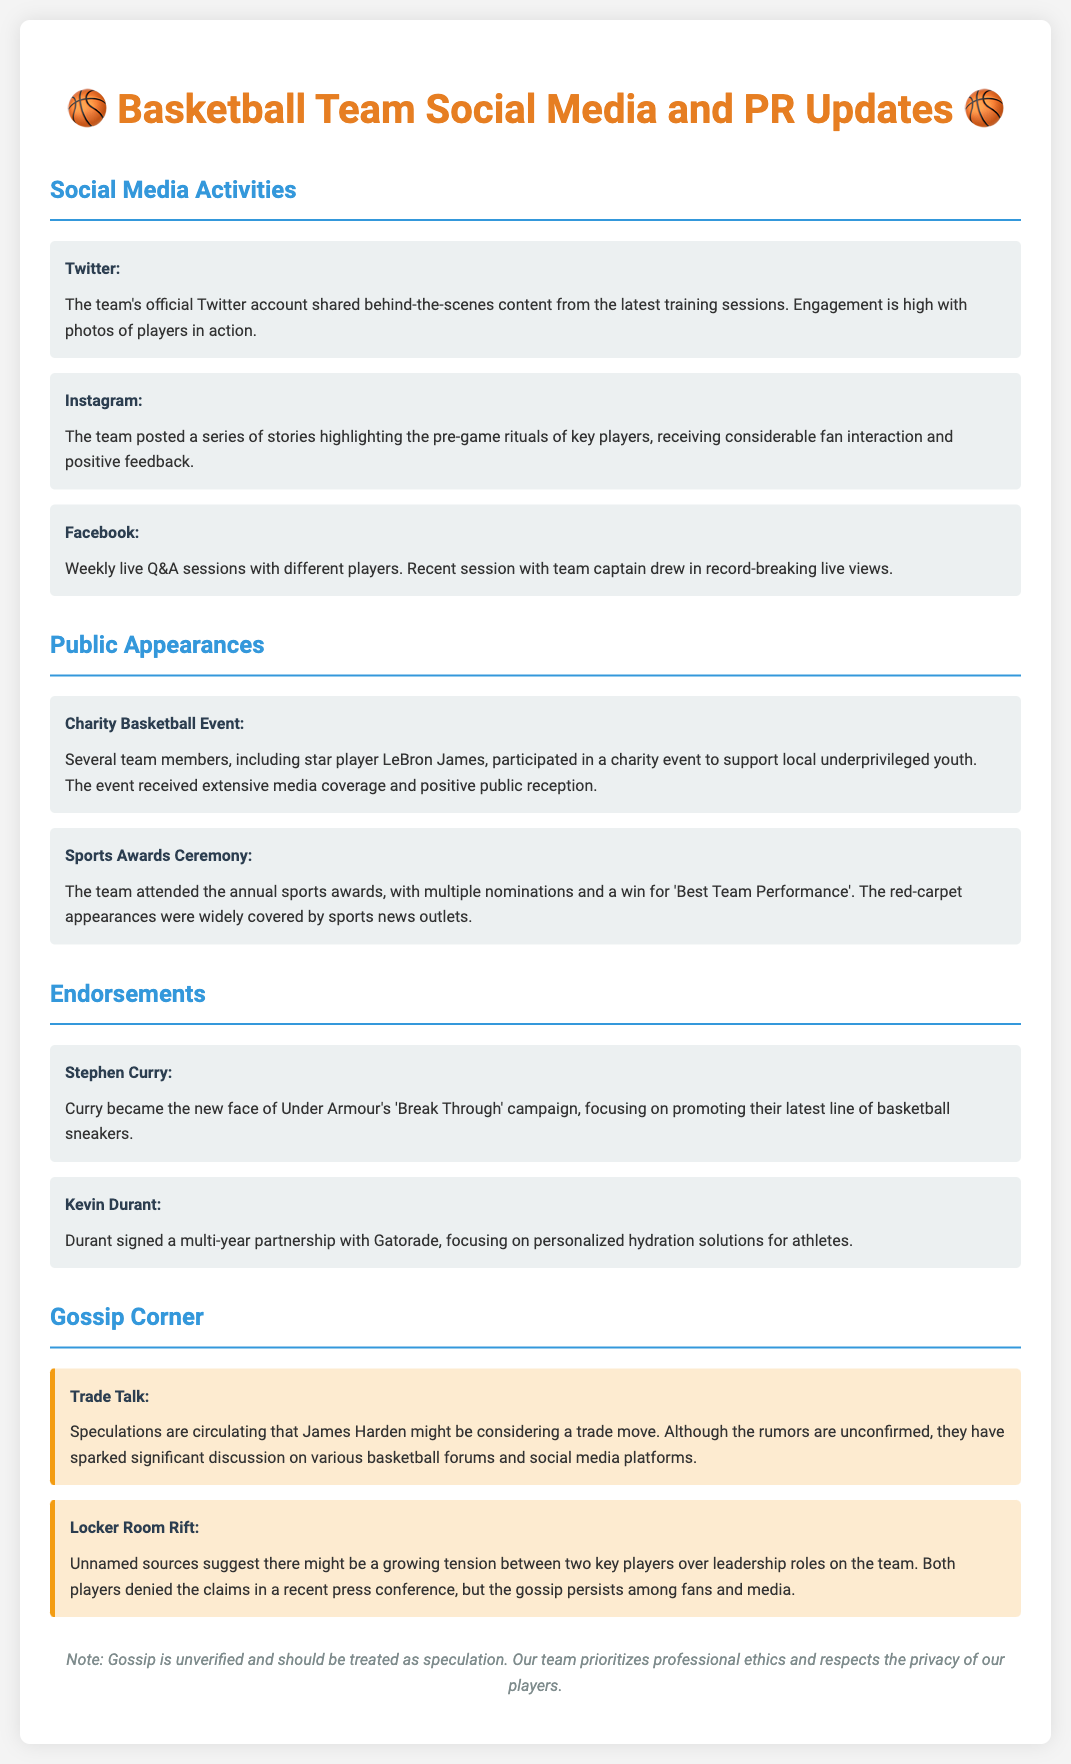What social media platform showcased behind-the-scenes training content? The platform mentioned in the document for showcasing behind-the-scenes training content is Twitter.
Answer: Twitter Which player is the face of Under Armour's 'Break Through' campaign? The document states that Stephen Curry became the new face of Under Armour's 'Break Through' campaign.
Answer: Stephen Curry What event did LeBron James participate in for charity? The document describes a charity basketball event that LeBron James participated in to support local underprivileged youth.
Answer: Charity Basketball Event How many players attended the annual sports awards? The document does not specify an exact number of players but indicates that several team members attended the sports awards.
Answer: Several What is the rumor circulating about James Harden? The document mentions speculations that James Harden might be considering a trade move.
Answer: Trade move Which player signed a partnership with Gatorade? The document specifies that Kevin Durant signed a multi-year partnership with Gatorade.
Answer: Kevin Durant What kind of feedback did the Instagram pre-game ritual stories receive? The document states that the Instagram stories received considerable fan interaction and positive feedback.
Answer: Positive feedback What were two players reportedly involved in a locker room rift? The document does not provide the names of the two players involved in the rumored locker room rift.
Answer: Unnamed players 